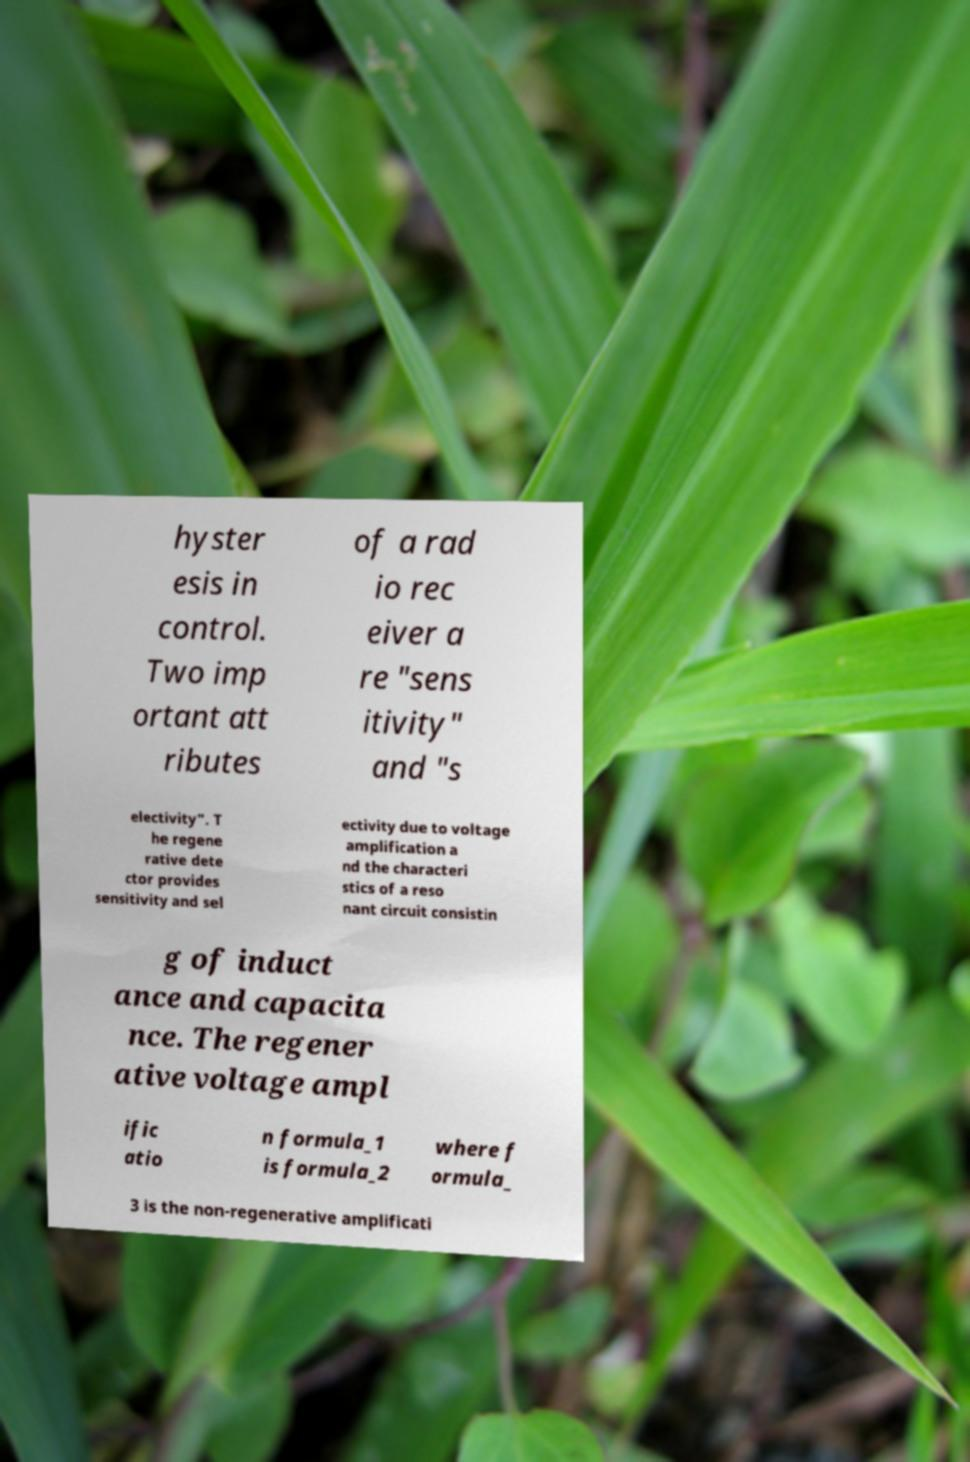Can you read and provide the text displayed in the image?This photo seems to have some interesting text. Can you extract and type it out for me? hyster esis in control. Two imp ortant att ributes of a rad io rec eiver a re "sens itivity" and "s electivity". T he regene rative dete ctor provides sensitivity and sel ectivity due to voltage amplification a nd the characteri stics of a reso nant circuit consistin g of induct ance and capacita nce. The regener ative voltage ampl ific atio n formula_1 is formula_2 where f ormula_ 3 is the non-regenerative amplificati 